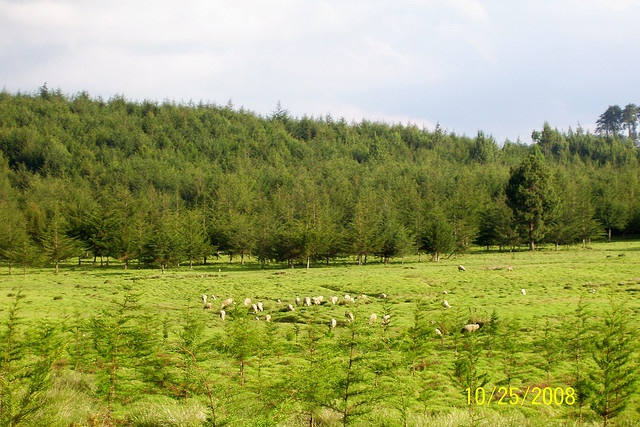Describe the objects in this image and their specific colors. I can see sheep in lightgray, khaki, olive, black, and tan tones, sheep in lightgray, khaki, darkgreen, lightyellow, and olive tones, sheep in lightgray, khaki, tan, and olive tones, sheep in lightgray, khaki, lightyellow, tan, and olive tones, and sheep in lightgray, khaki, lightyellow, black, and tan tones in this image. 